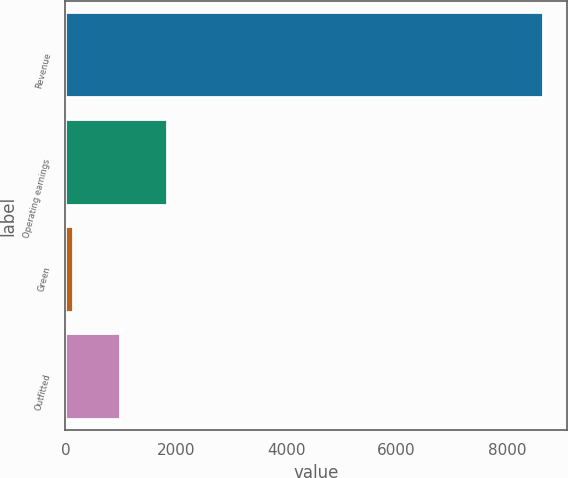Convert chart. <chart><loc_0><loc_0><loc_500><loc_500><bar_chart><fcel>Revenue<fcel>Operating earnings<fcel>Green<fcel>Outfitted<nl><fcel>8649<fcel>1845<fcel>144<fcel>994.5<nl></chart> 